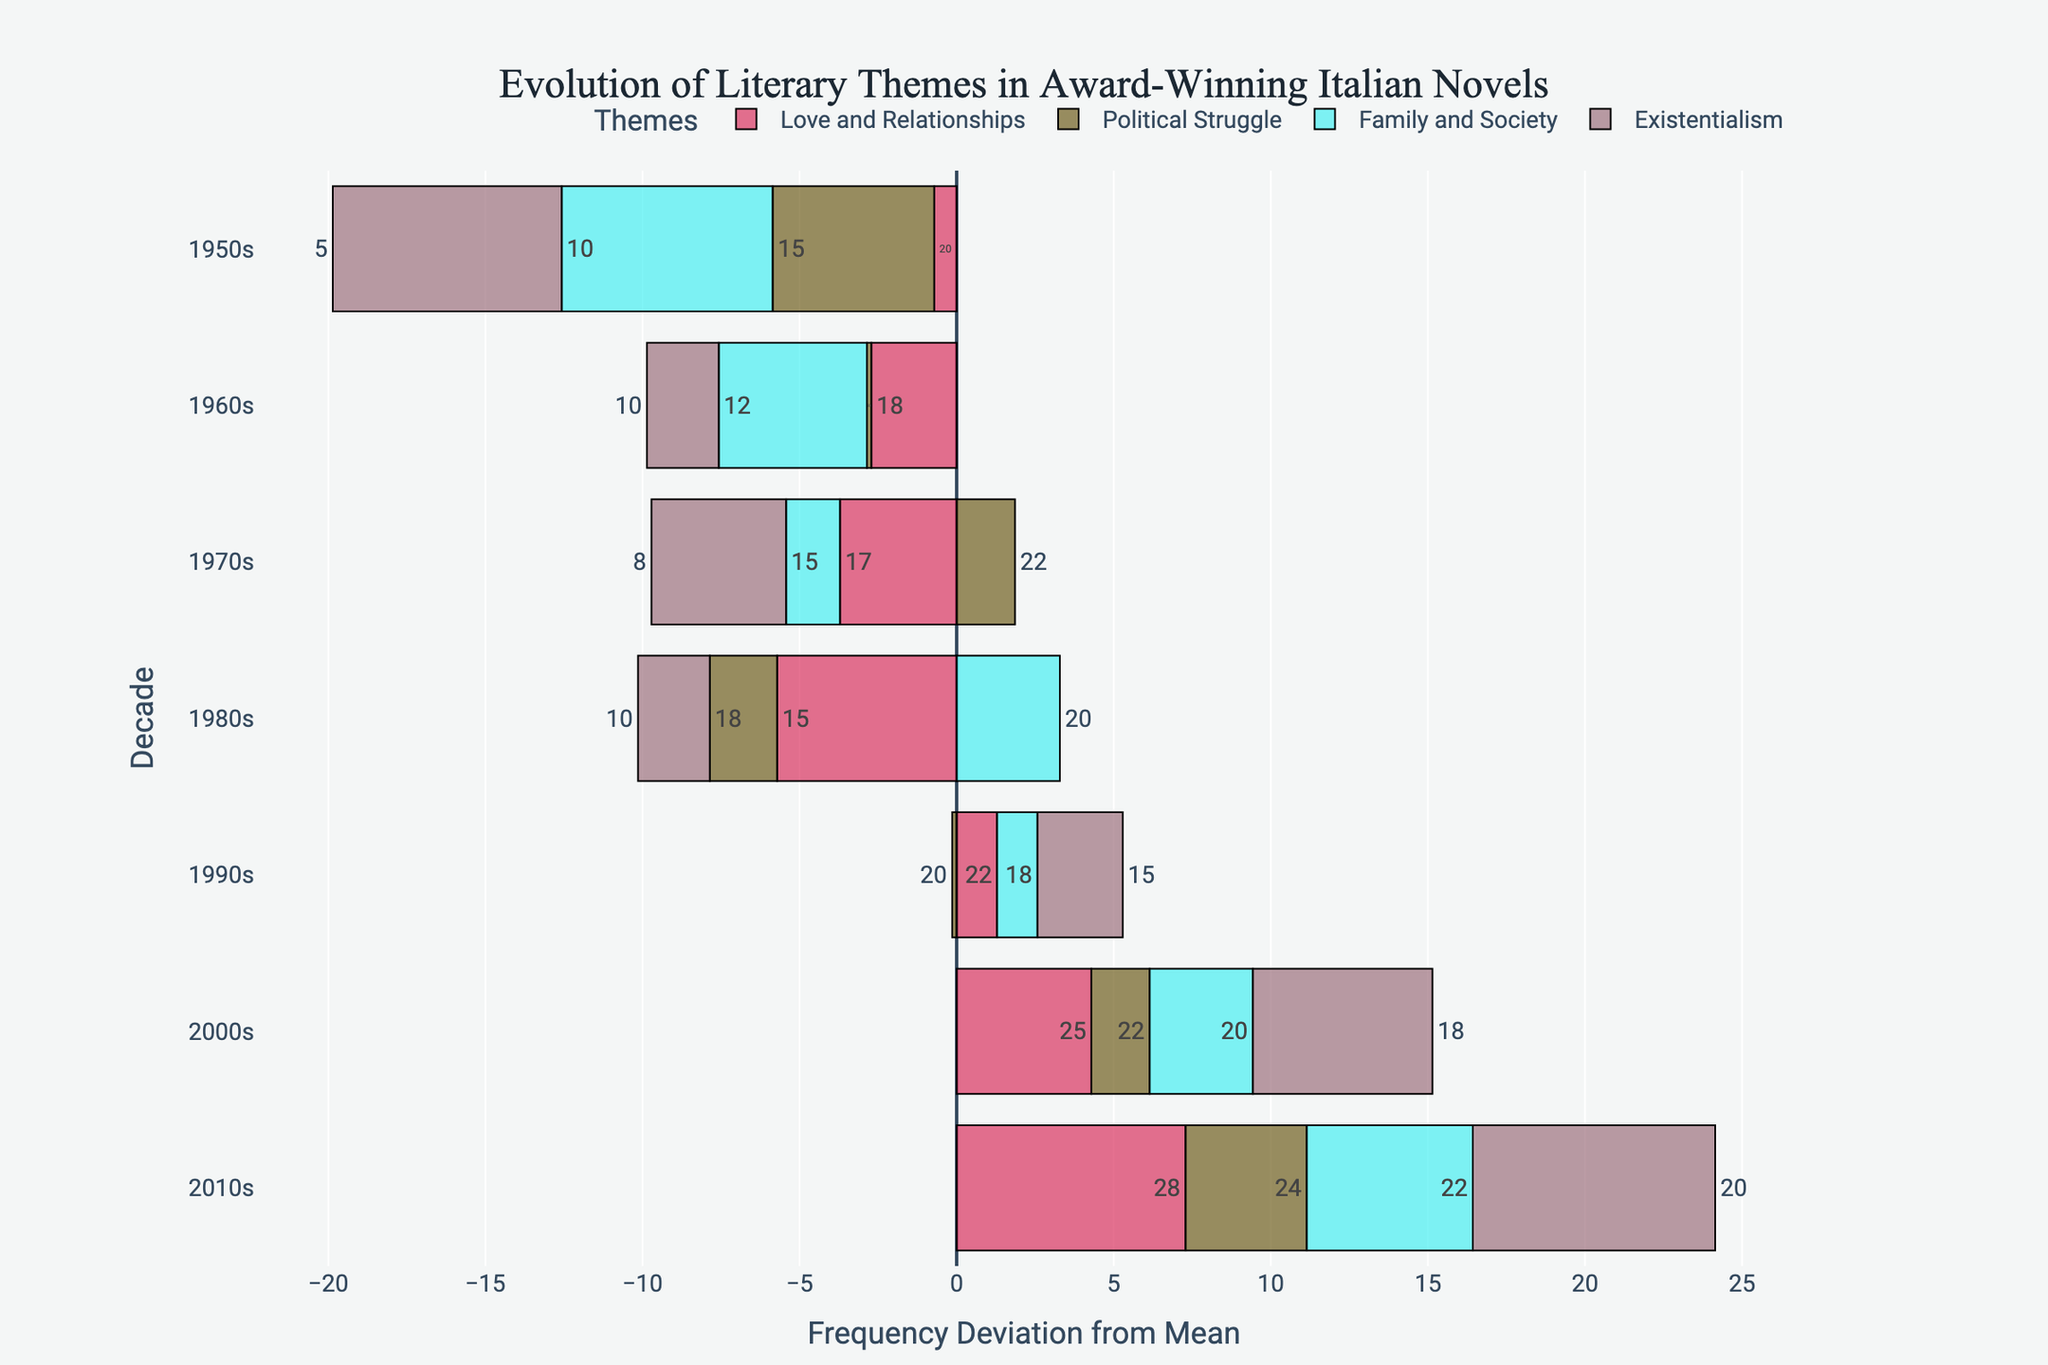What is the most frequent theme in award-winning Italian novels in the 2010s? To determine the most frequent theme in the 2010s, look at the bar lengths for the 2010s decade, where the longest bar represents the highest frequency. "Love and Relationships" has the longest bar with a frequency of 28, indicating it is the most frequent theme.
Answer: Love and Relationships Which theme shows the greatest increase in frequency from the 1950s to the 2010s? To find the theme with the greatest increase, compare the difference in frequencies between the 2010s and the 1950s for each theme. "Existentialism" increased from 5 in the 1950s to 20 in the 2010s, showing a rise of 15.
Answer: Existentialism How does the frequency of "Political Struggle" in the 1970s compare to the 2000s? Look at the bar lengths for "Political Struggle" in the 1970s and the 2000s. The frequency in the 1970s is 22, and in the 2000s, it is also 22. Both bars are of equal length, showing no change.
Answer: Equal Between "Family and Society" and "Existentialism," which theme had a notably higher frequency in the 1980s? In the 1980s, compare the bar lengths for "Family and Society" and "Existentialism." "Family and Society" has a frequency of 20, while "Existentialism" has a frequency of 10, making "Family and Society" twice as prevalent.
Answer: Family and Society How does the average frequency of "Love and Relationships" across all decades compare to the average of "Political Struggle"? First, calculate the average frequency of "Love and Relationships" across all decades: (20 + 18 + 17 + 15 + 22 + 25 + 28) / 7 = 145/7 = 20.71. Then, calculate the average for "Political Struggle": (15 + 20 + 22 + 18 + 20 + 22 + 24) / 7 = 141/7 = 20.14. Compare the results.
Answer: Love and Relationships: 20.71, Political Struggle: 20.14 What is the mean deviation from the average frequency for "Family and Society" in the 2000s? The overall mean frequency for "Family and Society" is the average of its values across all decades. First, calculate the average: (10 + 12 + 15 + 20 + 18 + 20 + 22) / 7 = 117/7 = 16.71. The deviation for the 2000s is 20 (2000s value) - 16.71 (average) = 3.29.
Answer: 3.29 